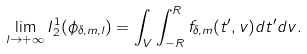<formula> <loc_0><loc_0><loc_500><loc_500>\lim _ { l \to + \infty } I _ { 2 } ^ { 1 } ( \phi _ { \delta , m , l } ) = \int _ { V } \int _ { - R } ^ { R } f _ { \delta , m } ( t ^ { \prime } , v ) d t ^ { \prime } d v .</formula> 